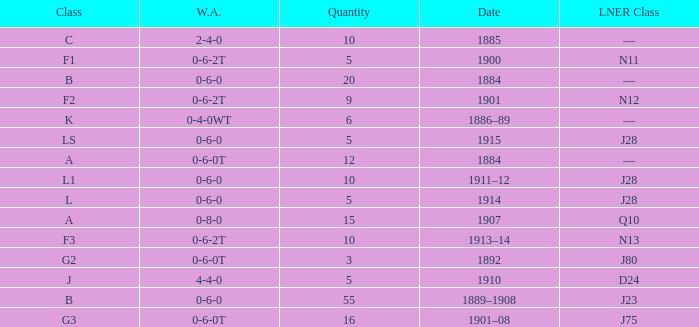What WA has a LNER Class of n13 and 10? 0-6-2T. 